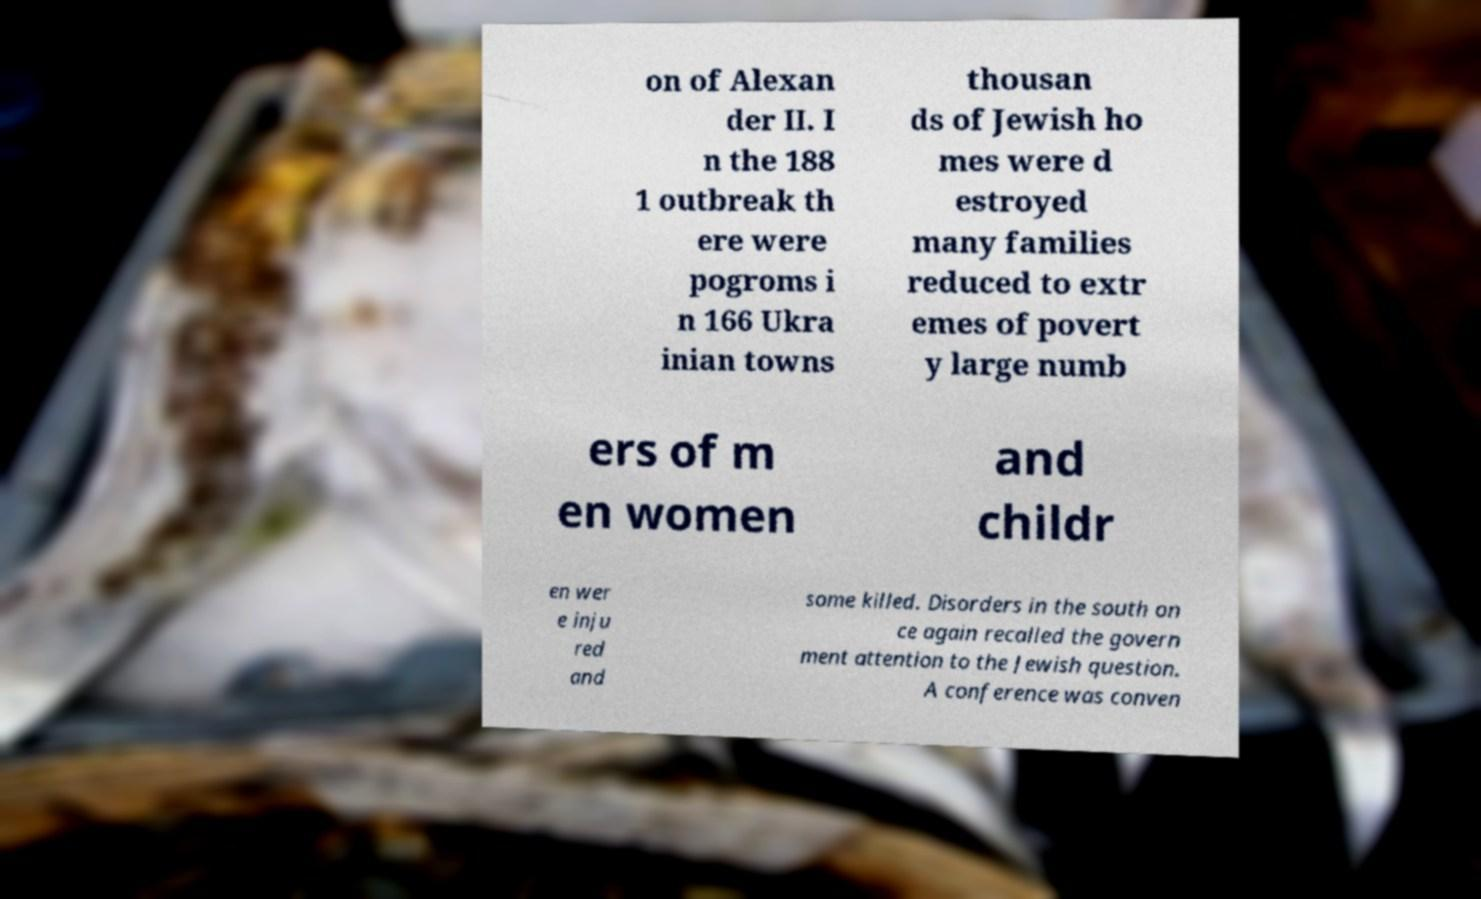For documentation purposes, I need the text within this image transcribed. Could you provide that? on of Alexan der II. I n the 188 1 outbreak th ere were pogroms i n 166 Ukra inian towns thousan ds of Jewish ho mes were d estroyed many families reduced to extr emes of povert y large numb ers of m en women and childr en wer e inju red and some killed. Disorders in the south on ce again recalled the govern ment attention to the Jewish question. A conference was conven 